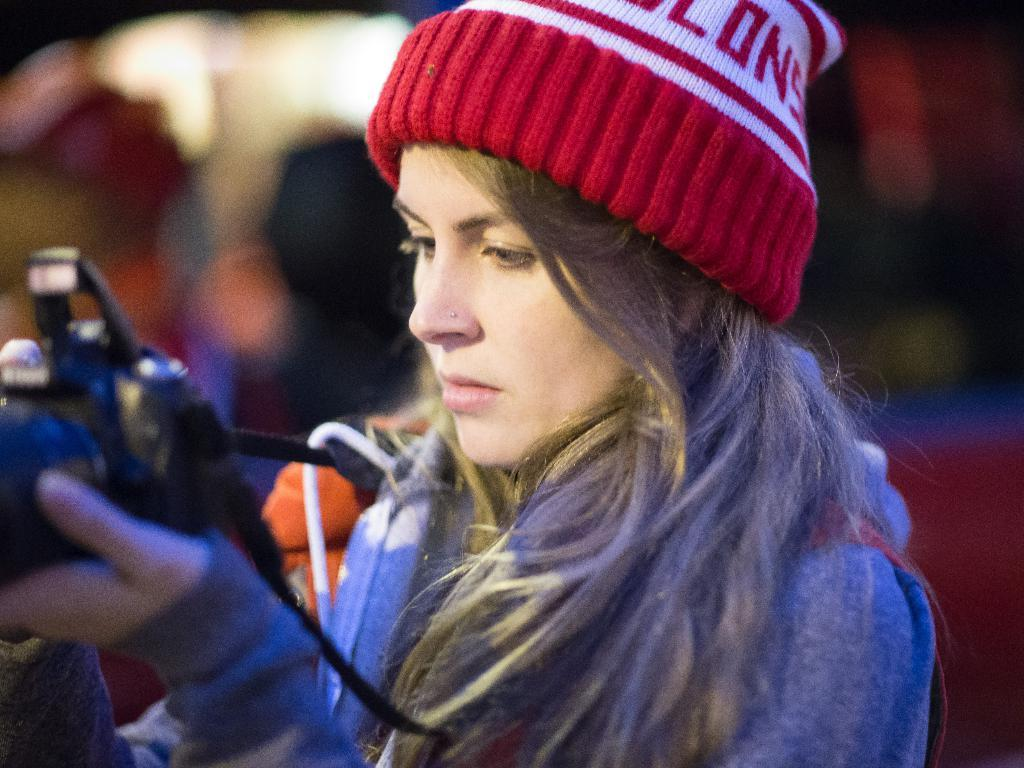What is the main subject of the image? The main subject of the image is a woman. What is the woman holding in the image? The woman is holding a camera. What type of hospital equipment can be seen in the image? There is no hospital equipment present in the image; it features a woman holding a camera. What type of destruction is visible in the image? There is no destruction present in the image; it features a woman holding a camera. 